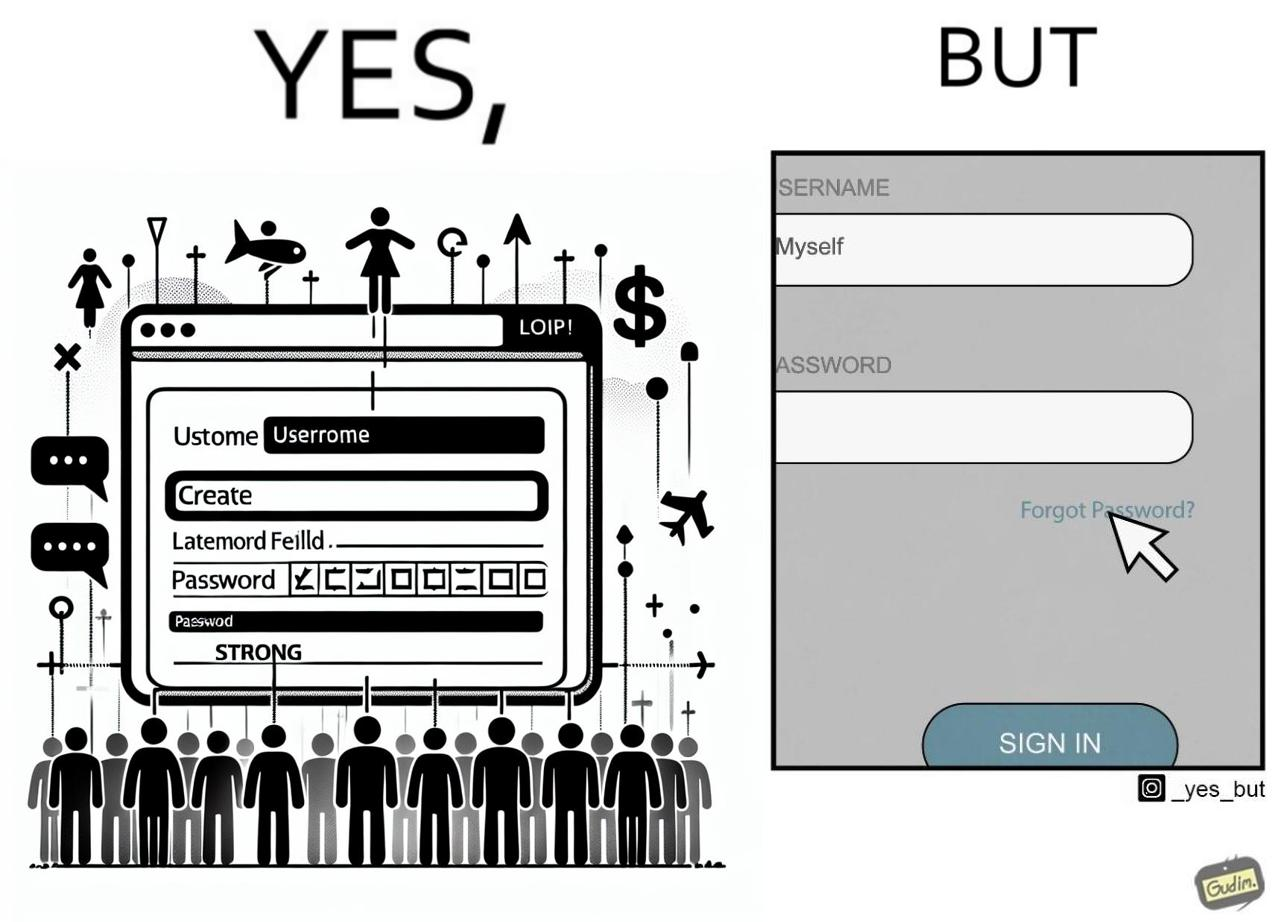What is shown in the left half versus the right half of this image? In the left part of the image: a screenshot of an account creation page of some site with login details filled in such as username and create password and password strength checker showing password as "strong" In the right part of the image: a screenshot of a login page of some site with username filled in and the user about to click on "Forget Password" link as the pointer is over the link 